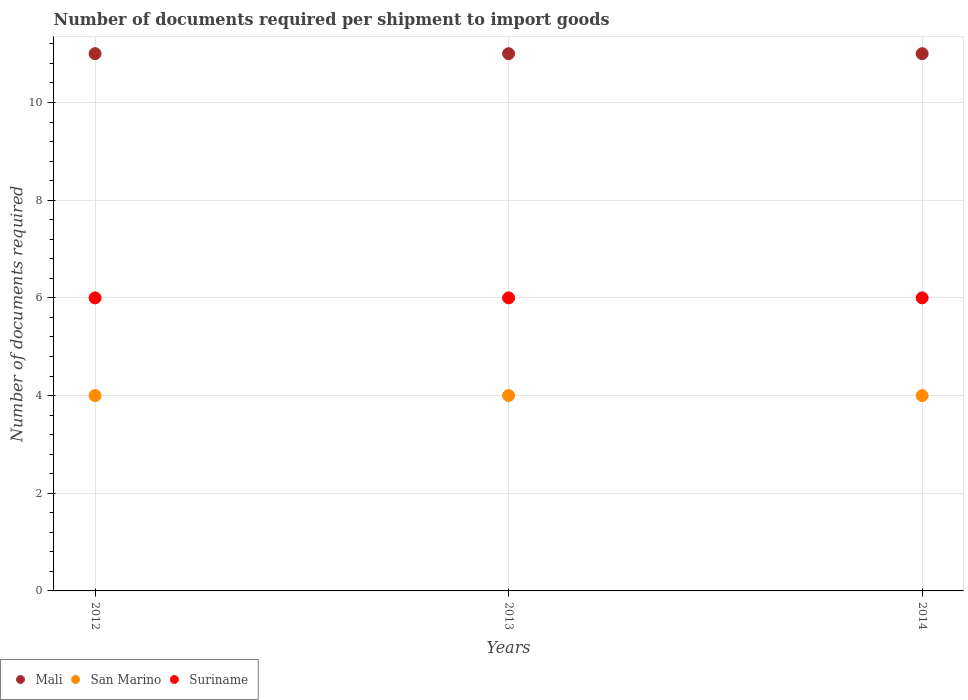What is the number of documents required per shipment to import goods in San Marino in 2013?
Provide a succinct answer. 4. Across all years, what is the minimum number of documents required per shipment to import goods in Mali?
Keep it short and to the point. 11. In which year was the number of documents required per shipment to import goods in Suriname maximum?
Provide a succinct answer. 2012. In which year was the number of documents required per shipment to import goods in San Marino minimum?
Make the answer very short. 2012. What is the difference between the number of documents required per shipment to import goods in Suriname in 2012 and that in 2013?
Make the answer very short. 0. What is the difference between the number of documents required per shipment to import goods in Mali in 2014 and the number of documents required per shipment to import goods in Suriname in 2012?
Make the answer very short. 5. In how many years, is the number of documents required per shipment to import goods in Mali greater than 8.8?
Keep it short and to the point. 3. What is the ratio of the number of documents required per shipment to import goods in Mali in 2012 to that in 2013?
Provide a succinct answer. 1. Is the difference between the number of documents required per shipment to import goods in San Marino in 2013 and 2014 greater than the difference between the number of documents required per shipment to import goods in Suriname in 2013 and 2014?
Ensure brevity in your answer.  No. Is the sum of the number of documents required per shipment to import goods in Mali in 2013 and 2014 greater than the maximum number of documents required per shipment to import goods in San Marino across all years?
Make the answer very short. Yes. Is it the case that in every year, the sum of the number of documents required per shipment to import goods in Mali and number of documents required per shipment to import goods in Suriname  is greater than the number of documents required per shipment to import goods in San Marino?
Give a very brief answer. Yes. How many dotlines are there?
Your answer should be compact. 3. What is the difference between two consecutive major ticks on the Y-axis?
Your answer should be compact. 2. Does the graph contain grids?
Ensure brevity in your answer.  Yes. Where does the legend appear in the graph?
Offer a terse response. Bottom left. How are the legend labels stacked?
Provide a short and direct response. Horizontal. What is the title of the graph?
Provide a short and direct response. Number of documents required per shipment to import goods. What is the label or title of the X-axis?
Offer a very short reply. Years. What is the label or title of the Y-axis?
Make the answer very short. Number of documents required. What is the Number of documents required of Mali in 2012?
Provide a succinct answer. 11. What is the Number of documents required of Suriname in 2012?
Offer a very short reply. 6. What is the Number of documents required in Mali in 2013?
Provide a short and direct response. 11. What is the Number of documents required of San Marino in 2013?
Provide a short and direct response. 4. What is the Number of documents required in Suriname in 2013?
Your response must be concise. 6. What is the Number of documents required of San Marino in 2014?
Your response must be concise. 4. What is the Number of documents required of Suriname in 2014?
Make the answer very short. 6. Across all years, what is the maximum Number of documents required in Mali?
Keep it short and to the point. 11. Across all years, what is the minimum Number of documents required of San Marino?
Provide a short and direct response. 4. Across all years, what is the minimum Number of documents required in Suriname?
Keep it short and to the point. 6. What is the difference between the Number of documents required in Mali in 2012 and that in 2013?
Provide a short and direct response. 0. What is the difference between the Number of documents required of Suriname in 2012 and that in 2013?
Provide a succinct answer. 0. What is the difference between the Number of documents required in Mali in 2012 and that in 2014?
Ensure brevity in your answer.  0. What is the difference between the Number of documents required in Mali in 2013 and that in 2014?
Your response must be concise. 0. What is the difference between the Number of documents required of San Marino in 2013 and that in 2014?
Your answer should be very brief. 0. What is the difference between the Number of documents required in Suriname in 2013 and that in 2014?
Make the answer very short. 0. What is the difference between the Number of documents required in Mali in 2012 and the Number of documents required in San Marino in 2013?
Your answer should be compact. 7. What is the difference between the Number of documents required in Mali in 2012 and the Number of documents required in San Marino in 2014?
Keep it short and to the point. 7. What is the difference between the Number of documents required of Mali in 2012 and the Number of documents required of Suriname in 2014?
Your answer should be compact. 5. What is the average Number of documents required of San Marino per year?
Keep it short and to the point. 4. In the year 2012, what is the difference between the Number of documents required in Mali and Number of documents required in Suriname?
Ensure brevity in your answer.  5. In the year 2013, what is the difference between the Number of documents required in Mali and Number of documents required in San Marino?
Make the answer very short. 7. In the year 2013, what is the difference between the Number of documents required in San Marino and Number of documents required in Suriname?
Your answer should be compact. -2. In the year 2014, what is the difference between the Number of documents required of Mali and Number of documents required of San Marino?
Make the answer very short. 7. In the year 2014, what is the difference between the Number of documents required of Mali and Number of documents required of Suriname?
Provide a succinct answer. 5. What is the ratio of the Number of documents required of Mali in 2012 to that in 2013?
Your answer should be very brief. 1. What is the ratio of the Number of documents required in San Marino in 2012 to that in 2013?
Provide a short and direct response. 1. What is the ratio of the Number of documents required in Mali in 2012 to that in 2014?
Offer a terse response. 1. What is the ratio of the Number of documents required in Suriname in 2012 to that in 2014?
Provide a succinct answer. 1. What is the ratio of the Number of documents required of San Marino in 2013 to that in 2014?
Your response must be concise. 1. What is the ratio of the Number of documents required in Suriname in 2013 to that in 2014?
Make the answer very short. 1. What is the difference between the highest and the second highest Number of documents required of San Marino?
Your response must be concise. 0. What is the difference between the highest and the lowest Number of documents required in Mali?
Provide a short and direct response. 0. What is the difference between the highest and the lowest Number of documents required in San Marino?
Give a very brief answer. 0. What is the difference between the highest and the lowest Number of documents required of Suriname?
Offer a very short reply. 0. 